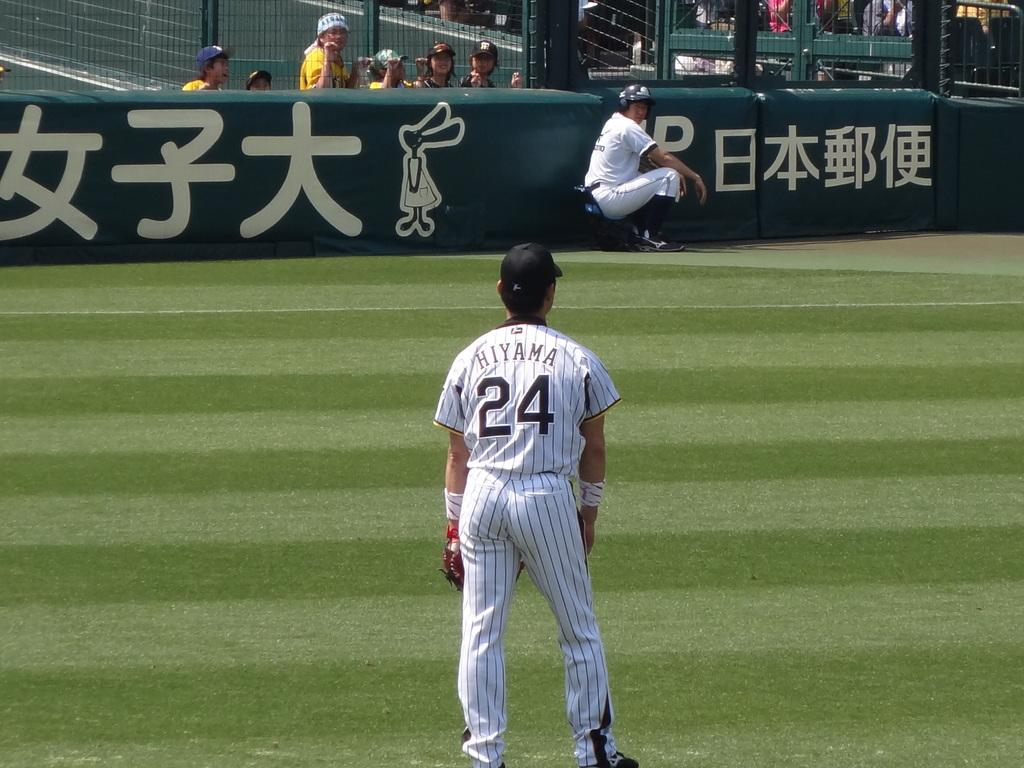How many people can be seen in the image? There is a person standing and a person sitting in the image, making a total of two people. What type of animals are in the image? There are birds in the image. What architectural feature is present in the image? There are iron grilles in the image. What can be seen in the background of the image? There is a group of people in the background of the image. Where is the cobweb located in the image? There is no cobweb present in the image. What type of sack is being carried by the person sitting in the image? There is no sack visible in the image; the person sitting is not carrying anything. 